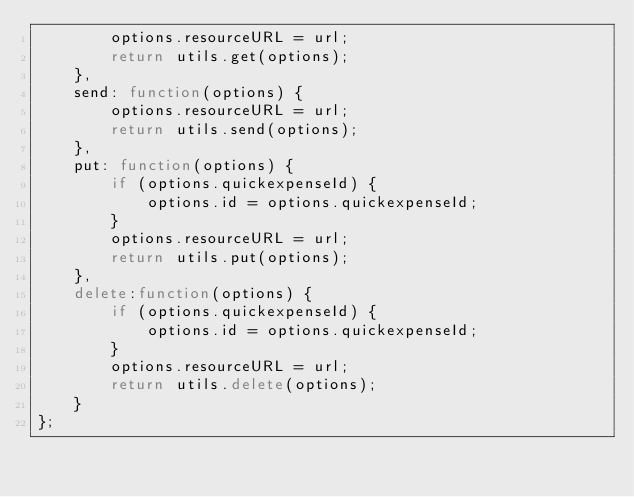Convert code to text. <code><loc_0><loc_0><loc_500><loc_500><_JavaScript_>        options.resourceURL = url;
        return utils.get(options);
    },
    send: function(options) {
        options.resourceURL = url;
        return utils.send(options);
    },
    put: function(options) {
        if (options.quickexpenseId) {
            options.id = options.quickexpenseId;
        }
        options.resourceURL = url;
        return utils.put(options);
    },
    delete:function(options) {
        if (options.quickexpenseId) {
            options.id = options.quickexpenseId;
        }
        options.resourceURL = url;
        return utils.delete(options);
    }
};</code> 